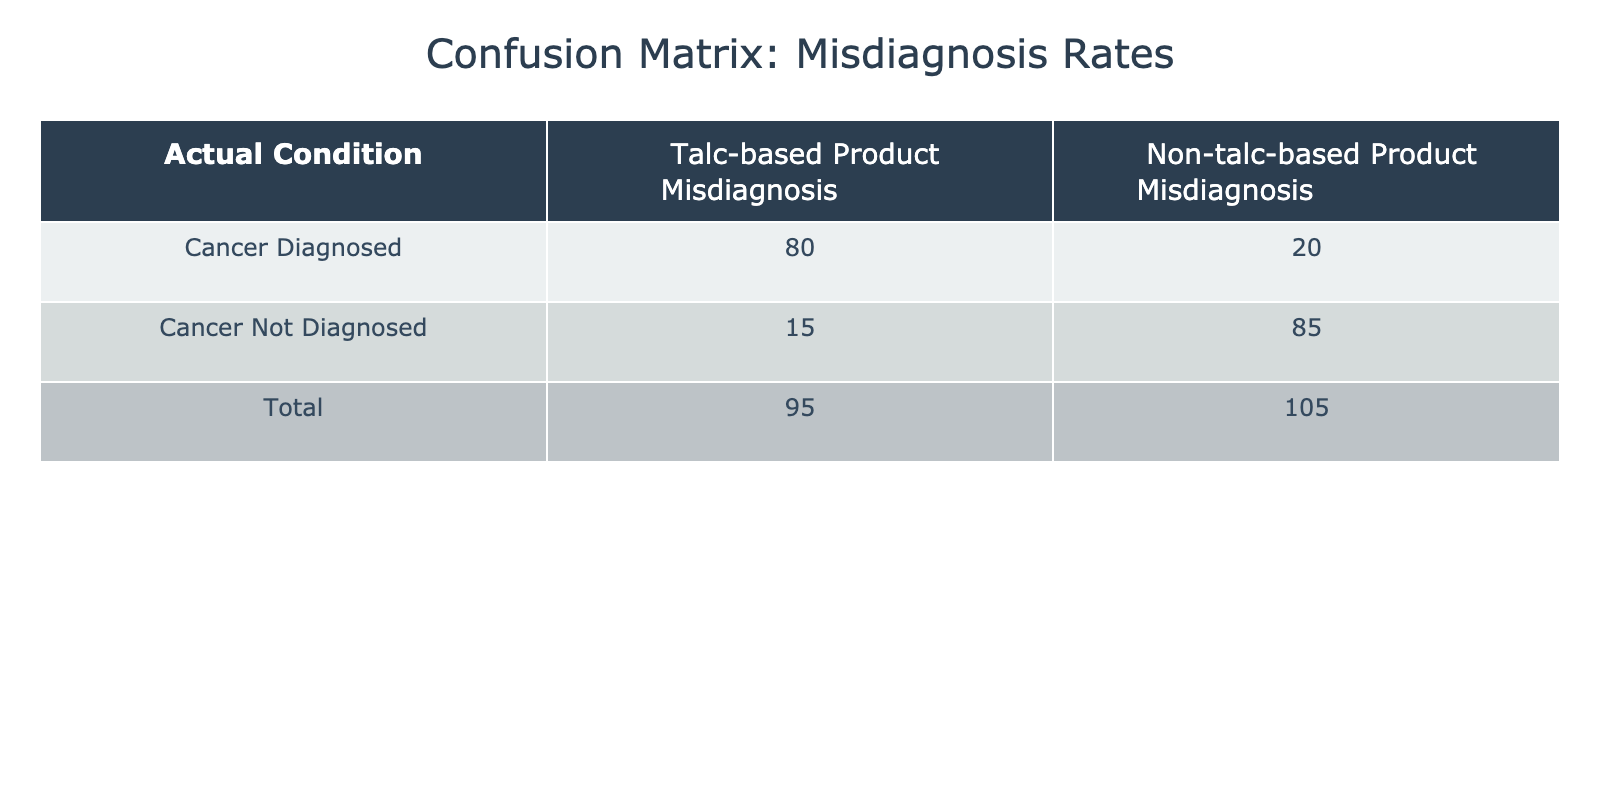What is the number of patients who were misdiagnosed with cancer while using talc-based products? According to the table, there are 80 patients who were diagnosed with cancer but misdiagnosed while using talc-based products.
Answer: 80 What is the total number of patients who were actually diagnosed with cancer? The total number of patients diagnosed with cancer is the sum of those diagnosed with cancer while using talc-based products and non-talc-based products: 80 (talc-based) + 20 (non-talc-based) = 100.
Answer: 100 What is the rate of misdiagnosis among patients not diagnosed with cancer who used non-talc-based products? To find this rate, we look at the number of patients not diagnosed with cancer using non-talc-based products, which is 85. Since the total of this group is 100 for non-cancer patients (15 talc-based + 85 non-talc-based), the rate is 85/100 = 0.85 or 85%.
Answer: 85% Is it true that more patients were misdiagnosed with cancer using talc-based products than not? Yes, when comparing the values, 80 patients were misdiagnosed with cancer using talc-based products, while only 20 were misdiagnosed using non-talc-based products, confirming that the statement is true.
Answer: Yes What is the difference in misdiagnosis rates between talc-based and non-talc-based products for patients diagnosed with cancer? To determine this, we compare the rates: for talc-based it's 80 misdiagnosed out of 95 total diagnosed (80/95 = 0.842). For non-talc-based, it's 20 misdiagnosed out of 105 total (20/105 = 0.190). The difference is 0.842 - 0.190 = 0.652, indicating a significantly higher rate for talc-users.
Answer: 0.652 What is the total number of patients who have not been diagnosed with cancer while using talc-based products? The total number of patients not diagnosed with cancer who used talc-based products is given as 15.
Answer: 15 How many total patients were involved in the study? To find the total, we combine all diagnosed and non-diagnosed patients: 80 (cancer diagnosed talc) + 15 (not diagnosed talc) + 20 (cancer diagnosed non-talc) + 85 (not diagnosed non-talc) = 200.
Answer: 200 What percentage of patients misdiagnosed with cancer used non-talc-based products? The total number of misdiagnosed cancer patients is 80 (talc) + 20 (non-talc) = 100. The non-talc misdiagnosed patients are 20, so the percentage is (20/100) * 100 = 20%.
Answer: 20% 